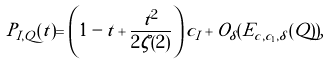Convert formula to latex. <formula><loc_0><loc_0><loc_500><loc_500>P _ { I , Q } ( t ) = \left ( 1 - t + \frac { t ^ { 2 } } { 2 \zeta ( 2 ) } \right ) c _ { I } + O _ { \delta } ( E _ { c , c _ { 1 } , \delta } ( Q ) ) ,</formula> 